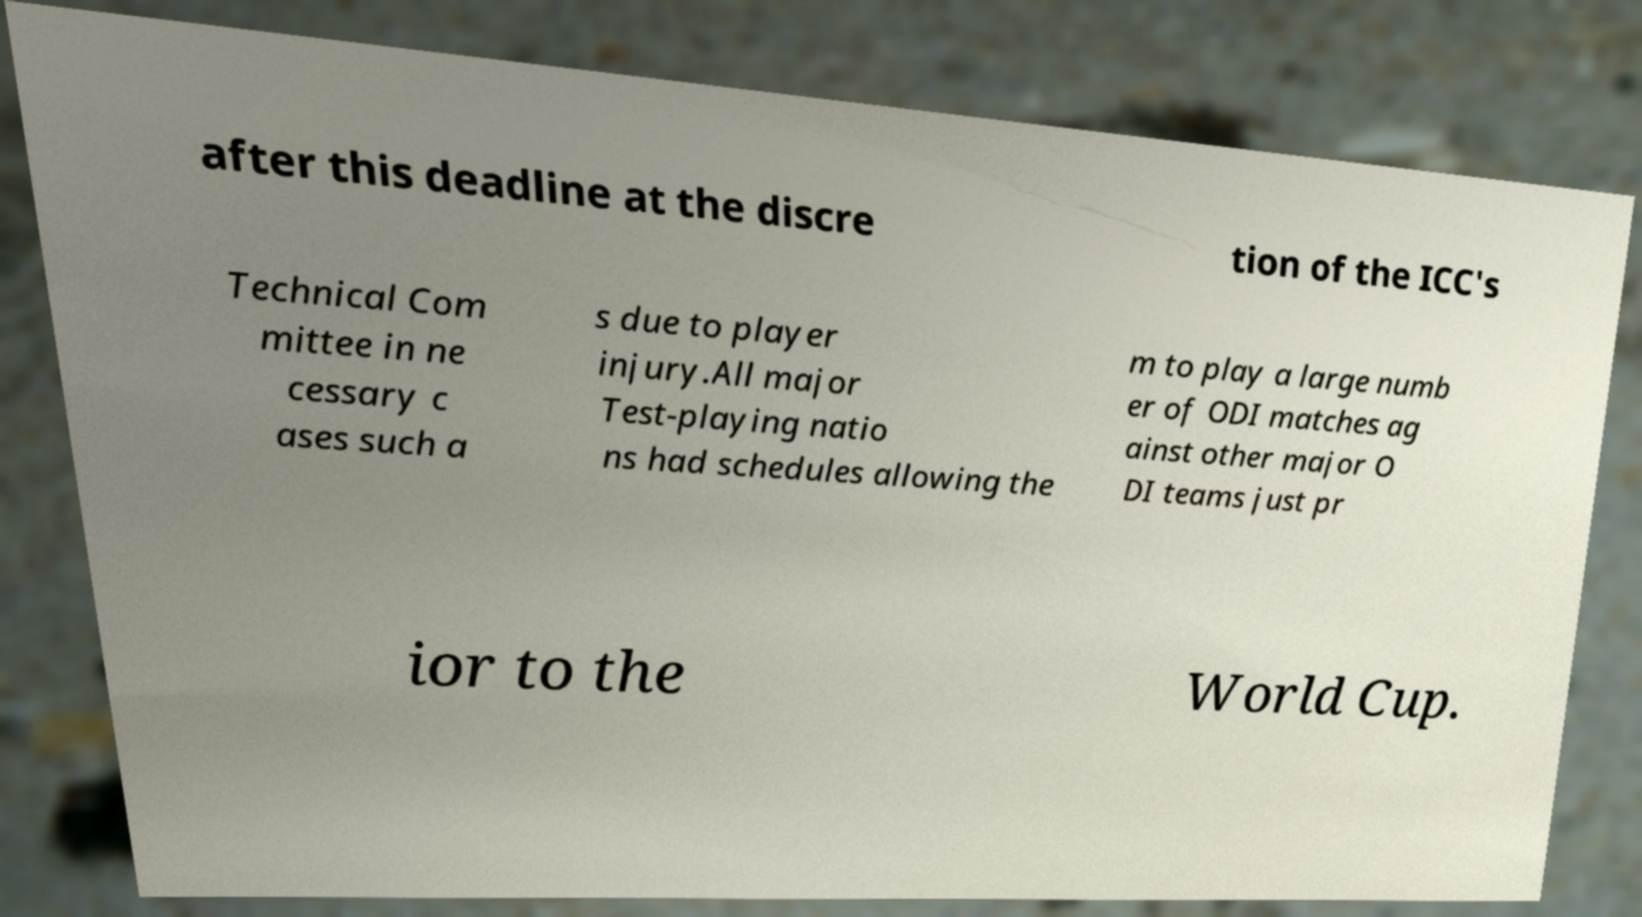Can you read and provide the text displayed in the image?This photo seems to have some interesting text. Can you extract and type it out for me? after this deadline at the discre tion of the ICC's Technical Com mittee in ne cessary c ases such a s due to player injury.All major Test-playing natio ns had schedules allowing the m to play a large numb er of ODI matches ag ainst other major O DI teams just pr ior to the World Cup. 